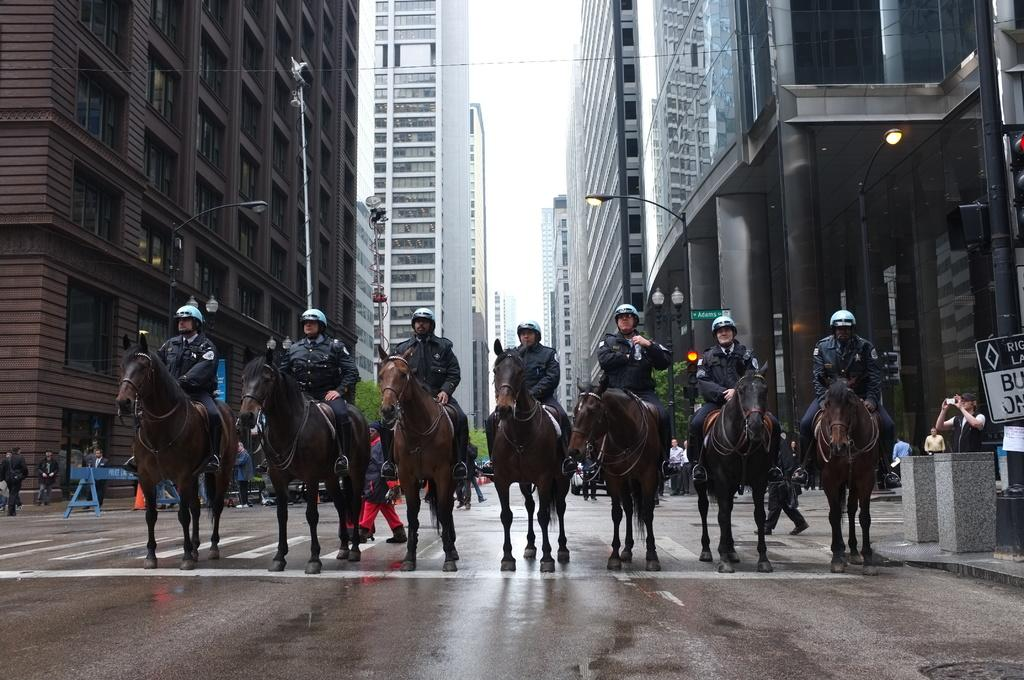What are the people doing in the image? The people are sitting on horses in the image. Where are the horses located? The horses are on a road in the image. Are there any other people present in the image? Yes, there are people on the road in the image. What can be seen in the background of the image? There are buildings visible near the sides of the road in the image. What type of basket is being used to catch the falling stars in the image? There is no basket or falling stars present in the image; it features people sitting on horses on a road with buildings in the background. 